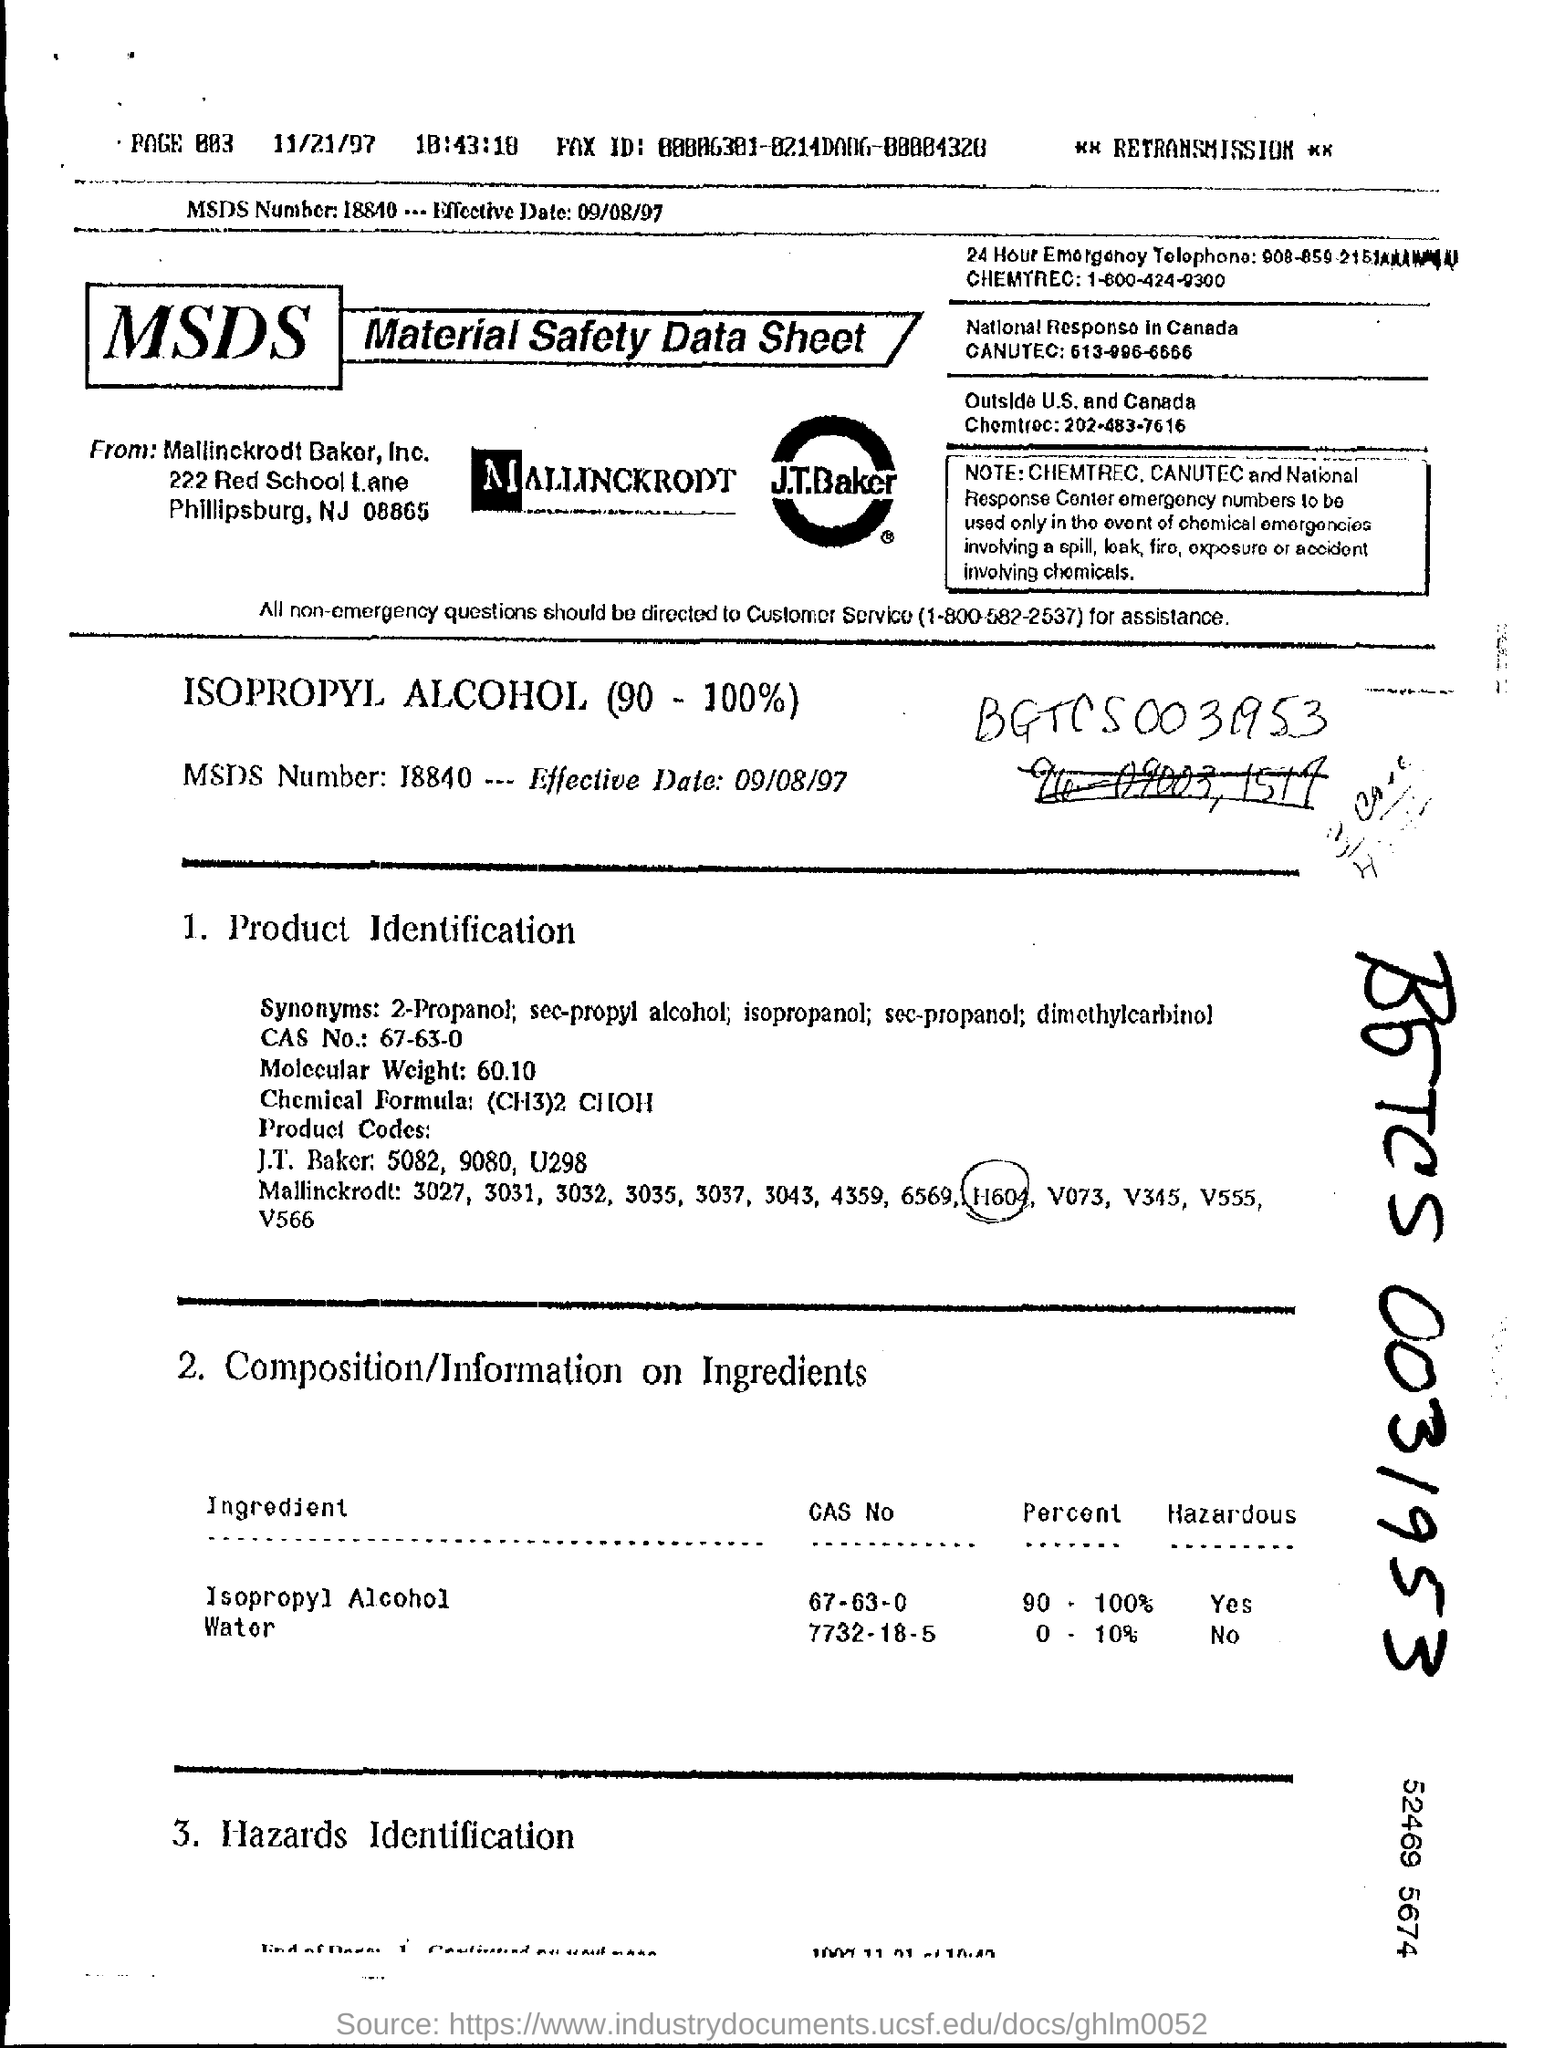Identify some key points in this picture. The chemical formula is (CH3)2 CHOH... The MSDS number is 18840. The molecular weight is 60.10.. Isopropyl alcohol has a CAS number of 67-63-0. The Chemical Abstracts Service (CAS) number for water is 7732-18-5. 